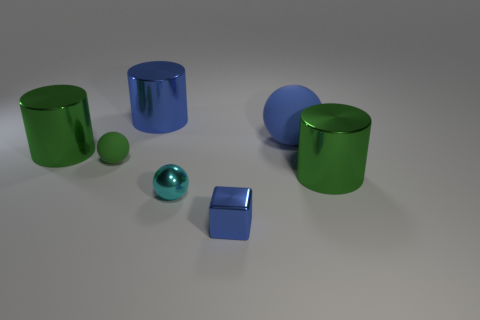Add 1 large blue things. How many objects exist? 8 Subtract all blocks. How many objects are left? 6 Add 5 blue metallic objects. How many blue metallic objects are left? 7 Add 5 tiny green rubber balls. How many tiny green rubber balls exist? 6 Subtract 1 green cylinders. How many objects are left? 6 Subtract all small cyan spheres. Subtract all large green cylinders. How many objects are left? 4 